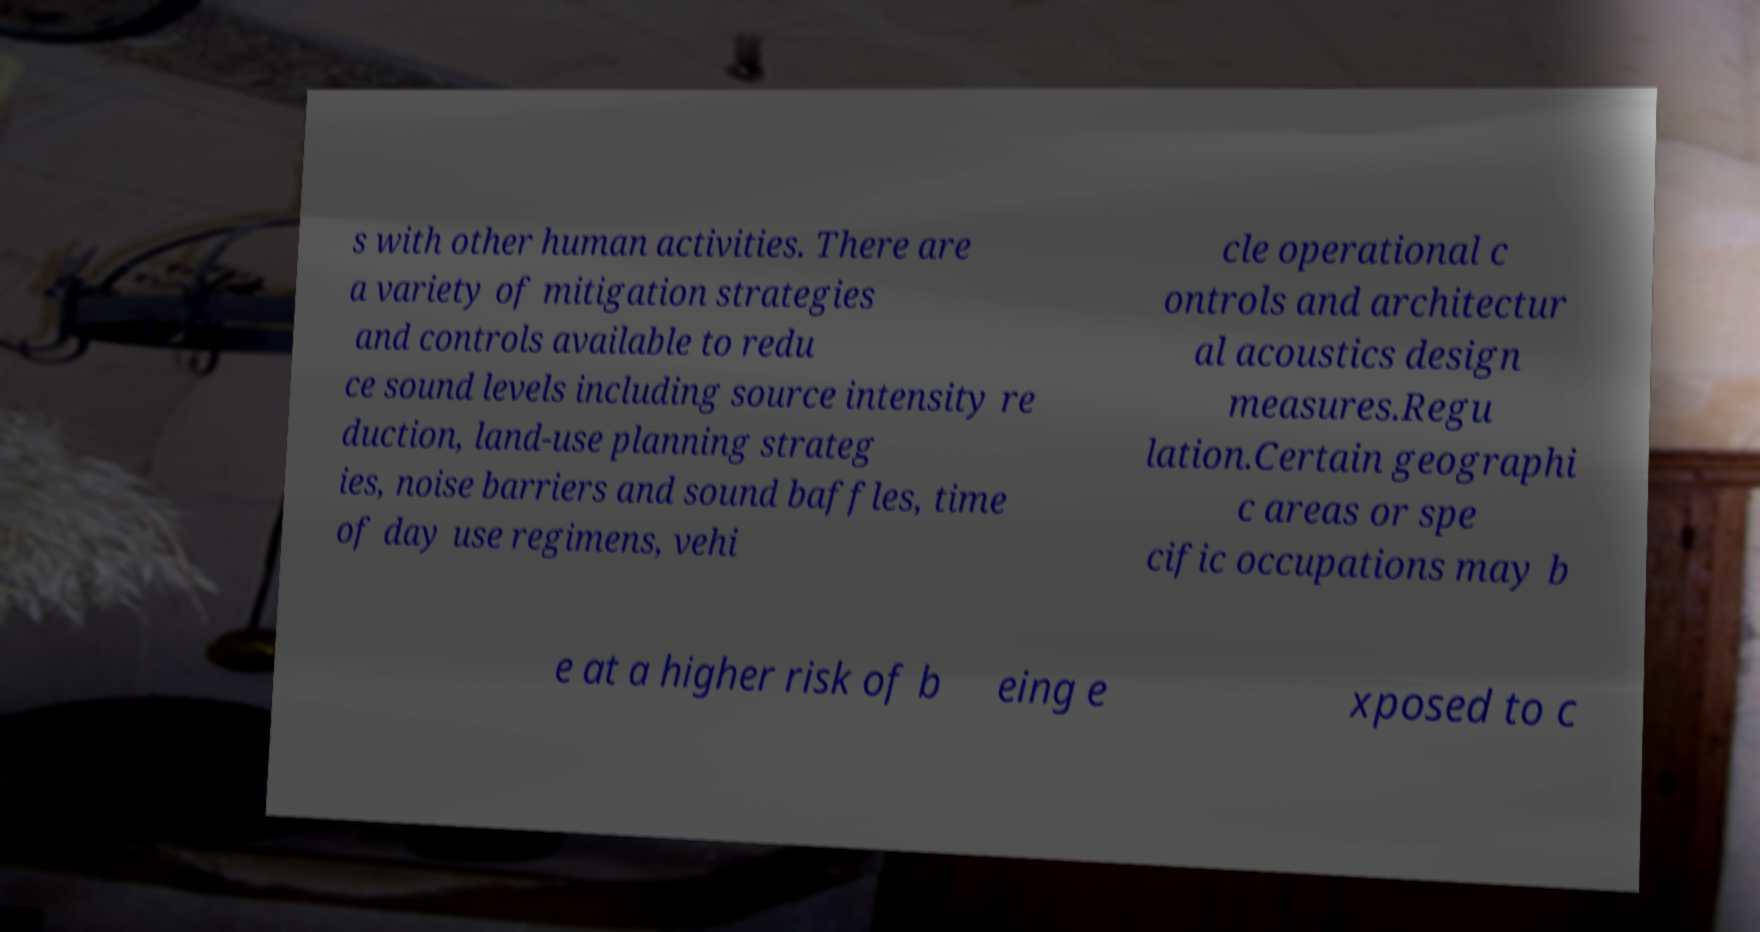Can you read and provide the text displayed in the image?This photo seems to have some interesting text. Can you extract and type it out for me? s with other human activities. There are a variety of mitigation strategies and controls available to redu ce sound levels including source intensity re duction, land-use planning strateg ies, noise barriers and sound baffles, time of day use regimens, vehi cle operational c ontrols and architectur al acoustics design measures.Regu lation.Certain geographi c areas or spe cific occupations may b e at a higher risk of b eing e xposed to c 